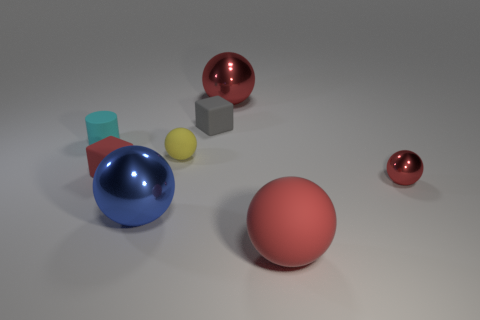Subtract all red spheres. How many were subtracted if there are1red spheres left? 2 Subtract all red blocks. How many blocks are left? 1 Add 1 rubber things. How many objects exist? 9 Subtract all tiny red spheres. How many spheres are left? 4 Subtract all blocks. How many objects are left? 6 Subtract all red cubes. How many brown spheres are left? 0 Subtract all small rubber cubes. Subtract all blue metallic things. How many objects are left? 5 Add 8 big metal things. How many big metal things are left? 10 Add 8 tiny yellow things. How many tiny yellow things exist? 9 Subtract 1 cyan cylinders. How many objects are left? 7 